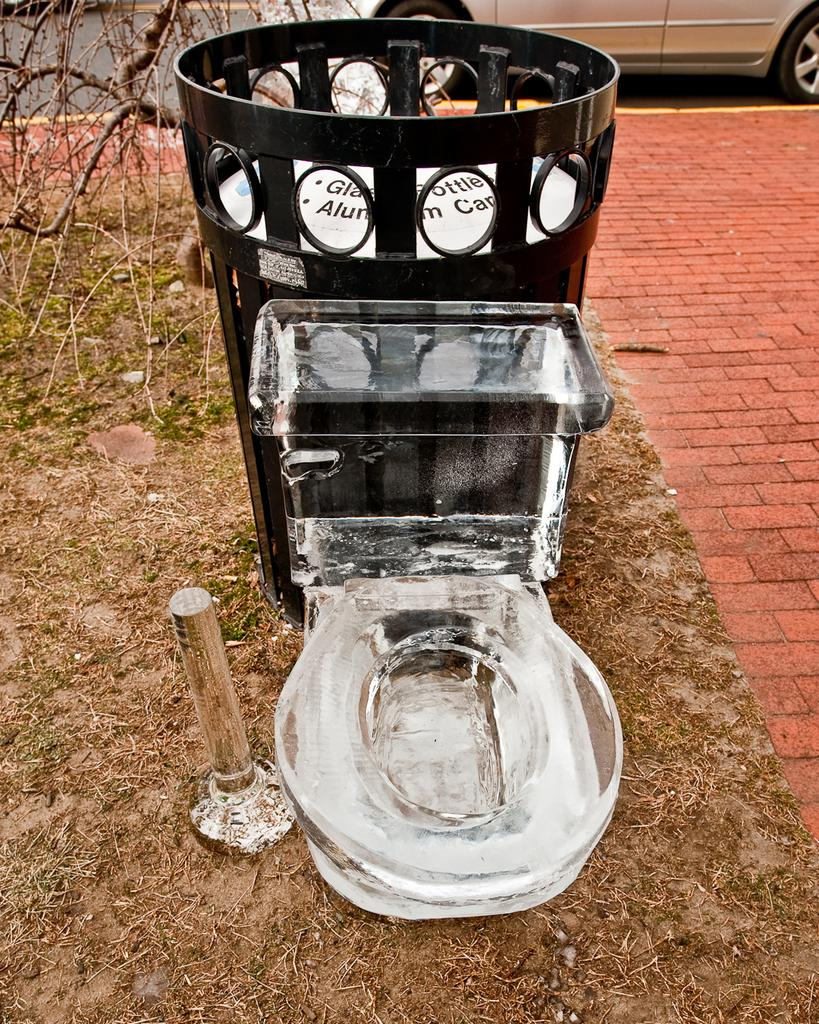<image>
Create a compact narrative representing the image presented. The can behind the toilet is intended for glass bottles and aluminum cans. 